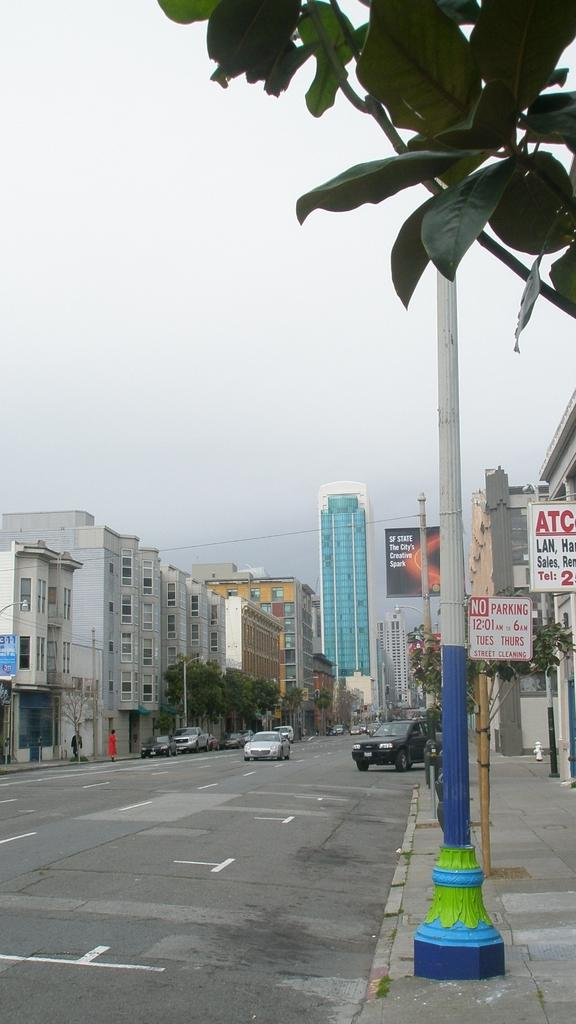What can be seen on the road in the image? There are cars on the road in the image. What is located on both sides of the road? Buildings, trees, banners, and poles are present on both sides of the road. What is the color of the sky in the image? The sky is white in color. What type of silver knot is tied around the banner on the left side of the road? There is no silver knot present on the banner in the image. 